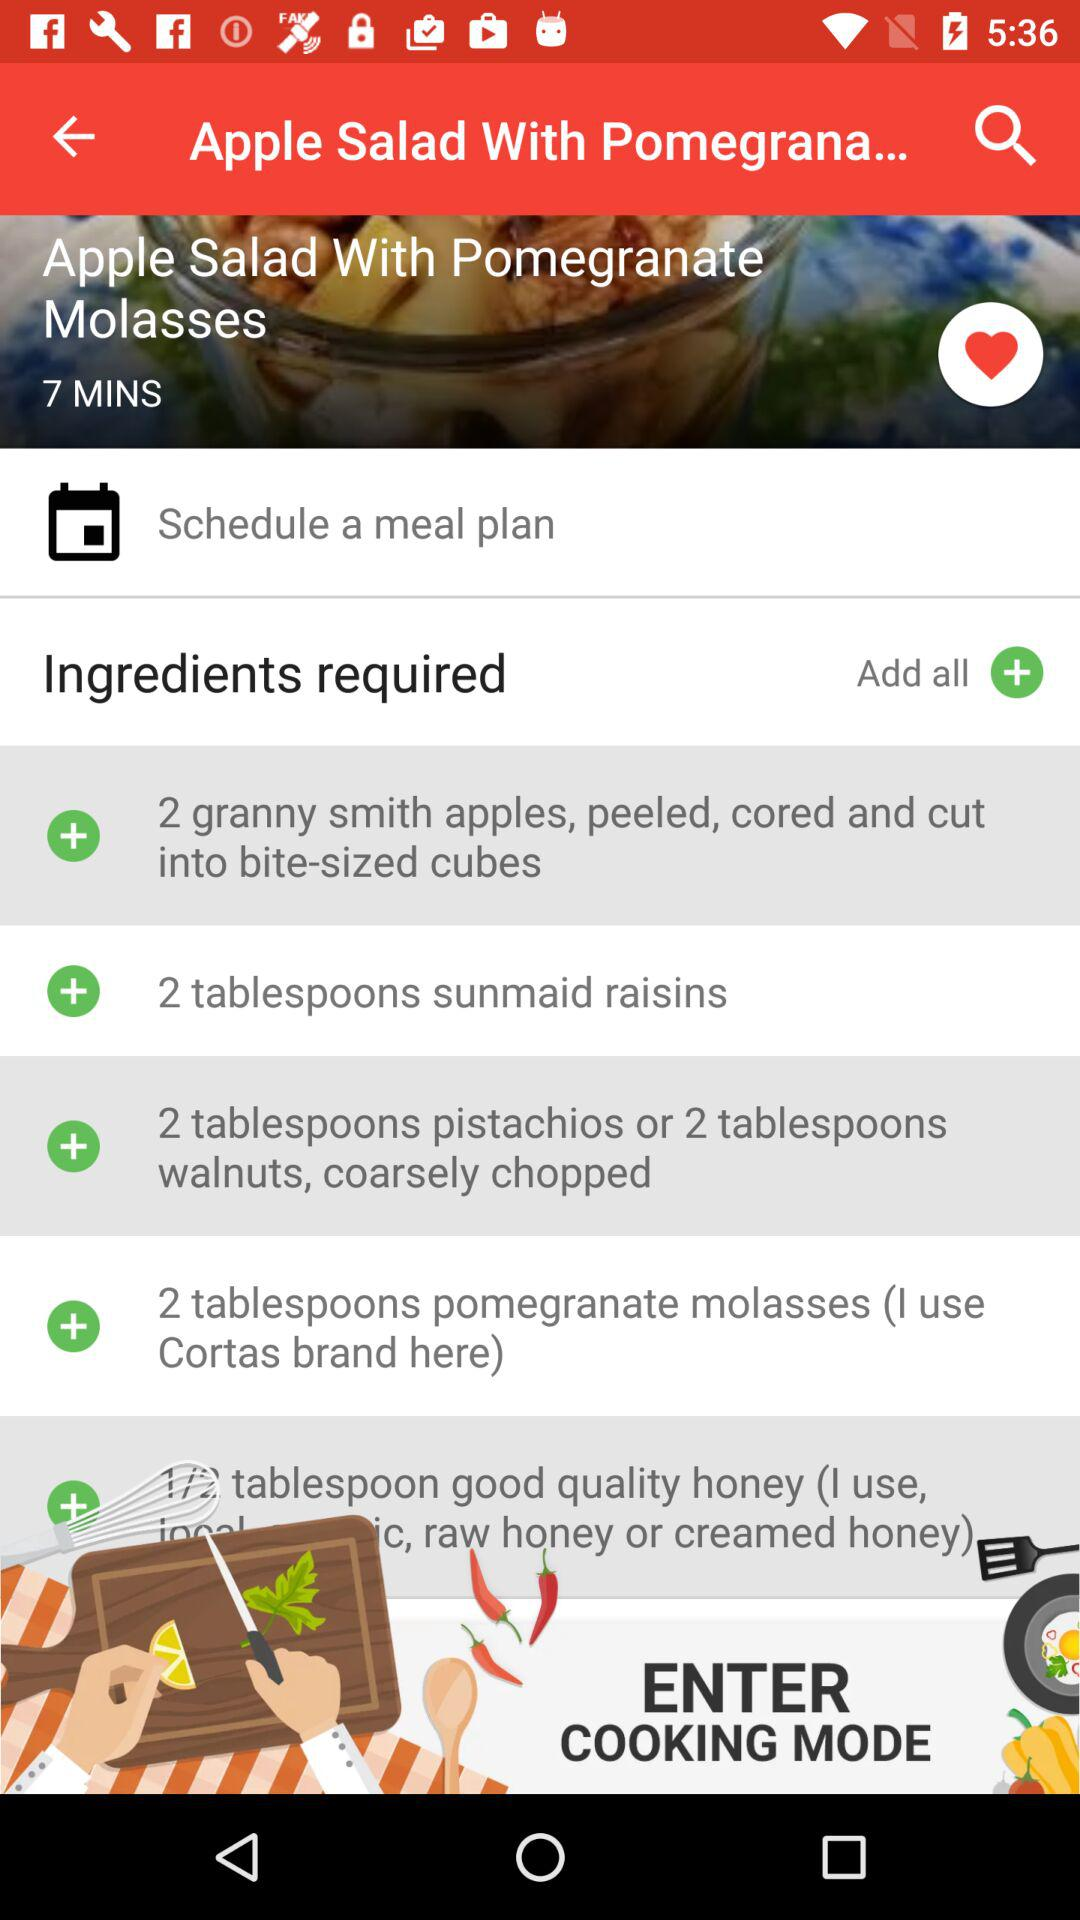What are the ingredients required to make "Apple Salad With Pomegranate Molasses"? The ingredients required are "2 granny smith apples, peeled, cored and cut into bite-sized cubes", "2 tablespoons sunmaid raisins", "2 tablespoons pistachios or 2 tablespoons walnuts, coarsely chopped", "2 tablespoons pomegranate molasses (I use Cortas brand here)" and "1/2 tablespoon good quality honey (I use, c, raw honey or creamed honey)". 